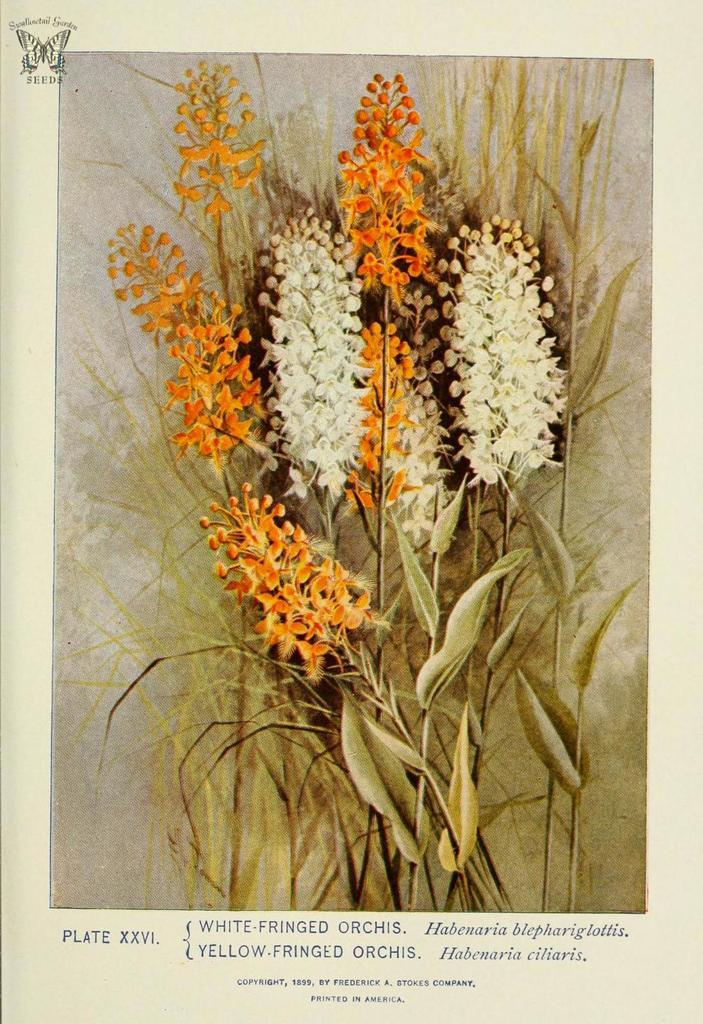What colors of flowers can be seen in the image? There are white and orange color flowers in the image. What else can be found on the ground in the image? Dry leaves are present in the image. Is there any text or writing visible in the image? Yes, there is text or writing on the image. What type of vest is being worn by the flowers in the image? There are no people or clothing items, including vests, present in the image. The image features flowers and dry leaves. 